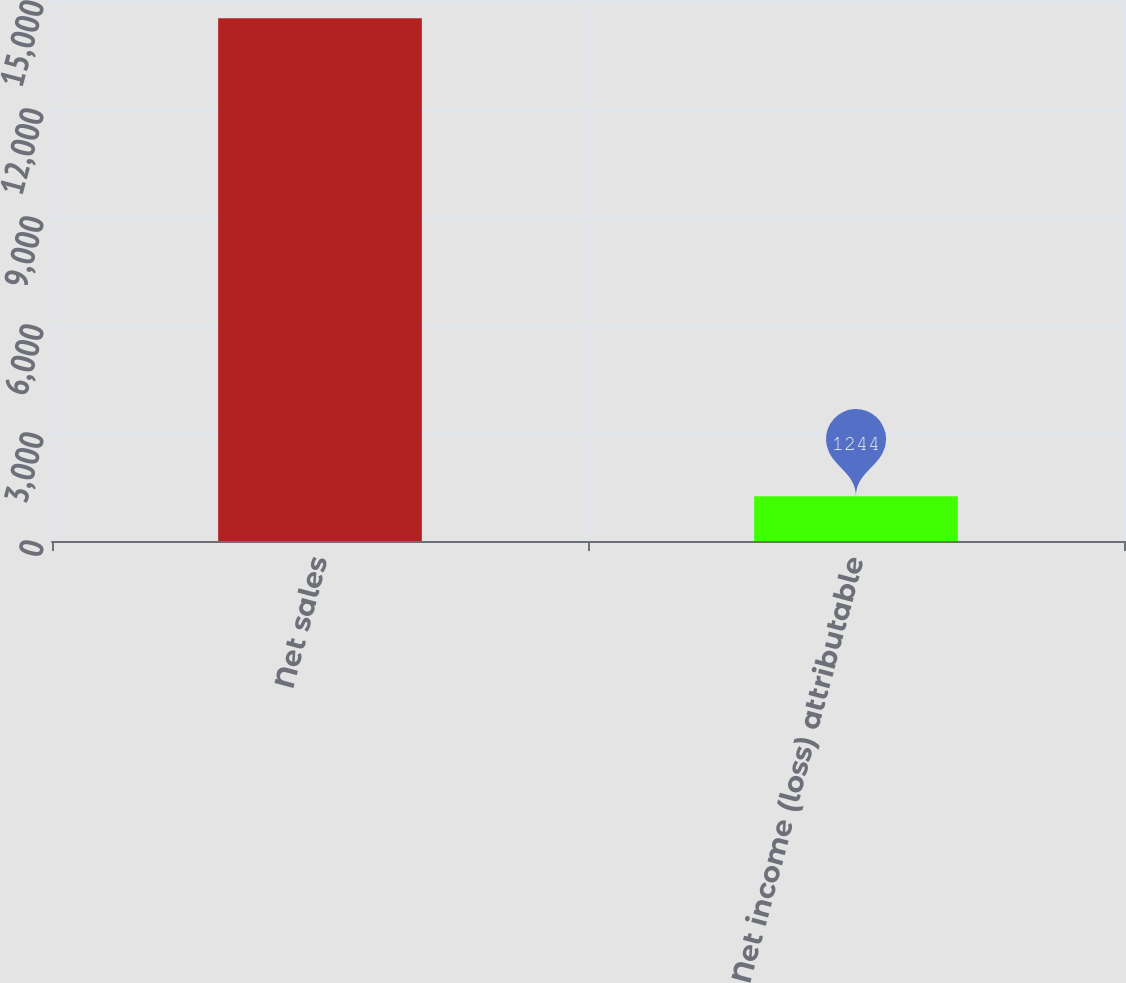Convert chart. <chart><loc_0><loc_0><loc_500><loc_500><bar_chart><fcel>Net sales<fcel>Net income (loss) attributable<nl><fcel>14523<fcel>1244<nl></chart> 